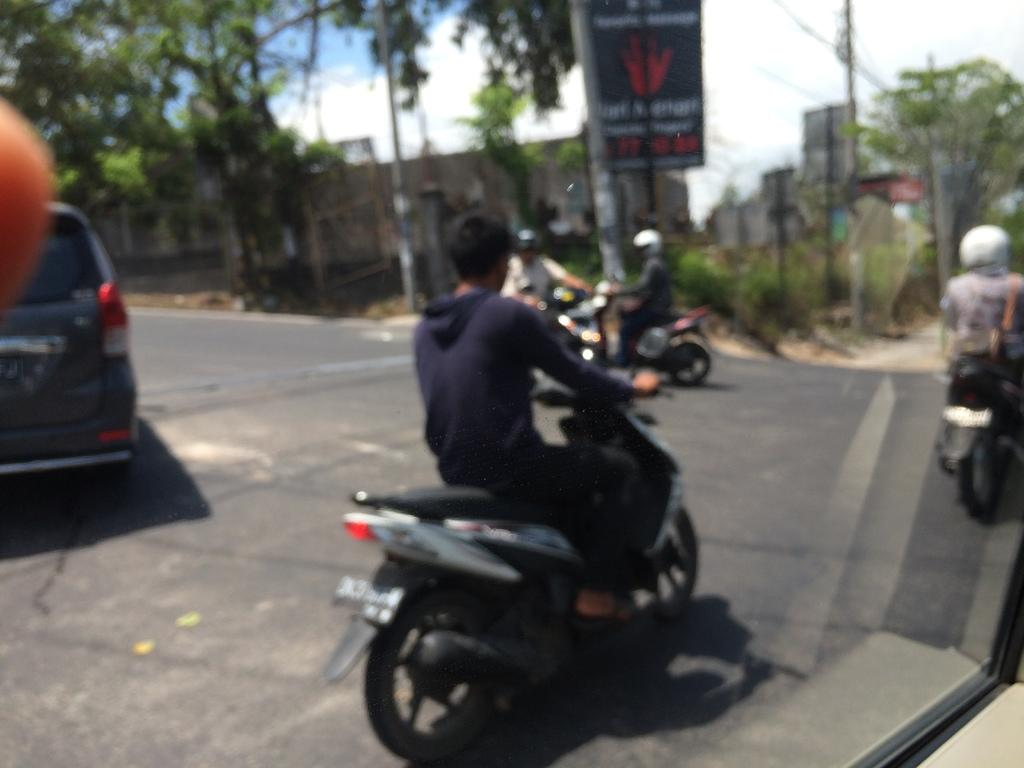What object is present in the image that has a transparent or translucent surface? There is a glass in the image. What can be seen through the glass in the image? Vehicles and people are visible through the glass. What type of natural scenery is visible in the background of the image? There are trees in the background of the image. What man-made structures can be seen in the background of the image? There are poles, boards, and buildings in the background of the image. Where is the rabbit hiding in the image? There is no rabbit present in the image. What type of clothing item is hanging on the pole in the image? There is no clothing item, such as a stocking, hanging on the pole in the image. 